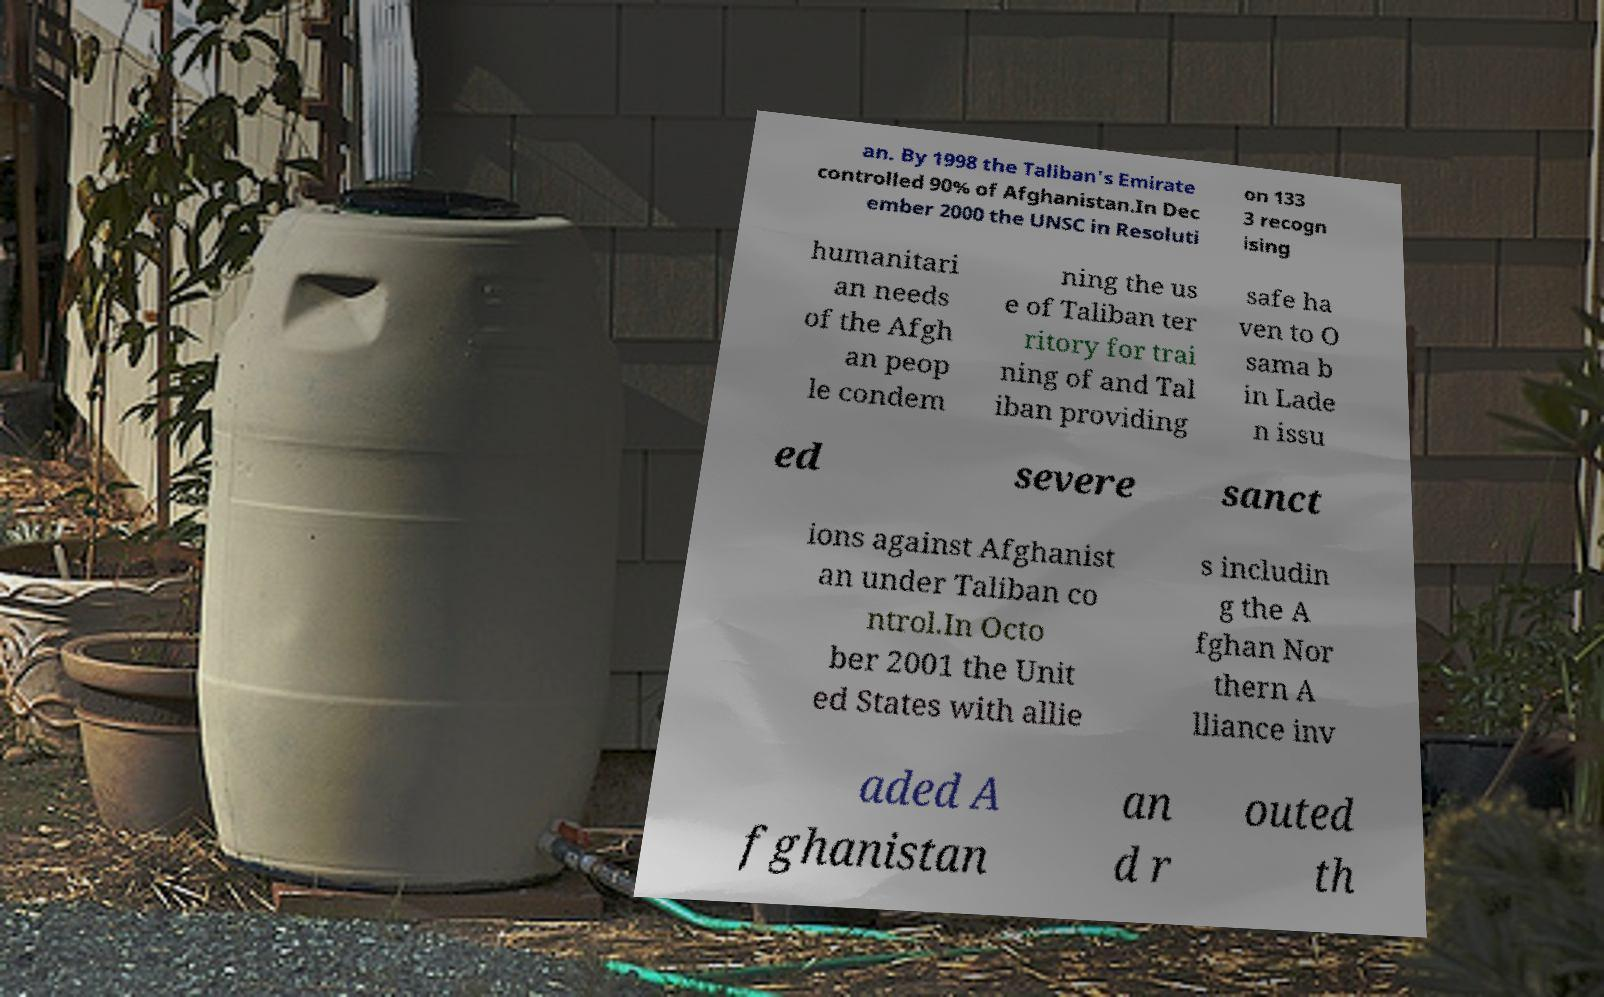Could you assist in decoding the text presented in this image and type it out clearly? an. By 1998 the Taliban's Emirate controlled 90% of Afghanistan.In Dec ember 2000 the UNSC in Resoluti on 133 3 recogn ising humanitari an needs of the Afgh an peop le condem ning the us e of Taliban ter ritory for trai ning of and Tal iban providing safe ha ven to O sama b in Lade n issu ed severe sanct ions against Afghanist an under Taliban co ntrol.In Octo ber 2001 the Unit ed States with allie s includin g the A fghan Nor thern A lliance inv aded A fghanistan an d r outed th 